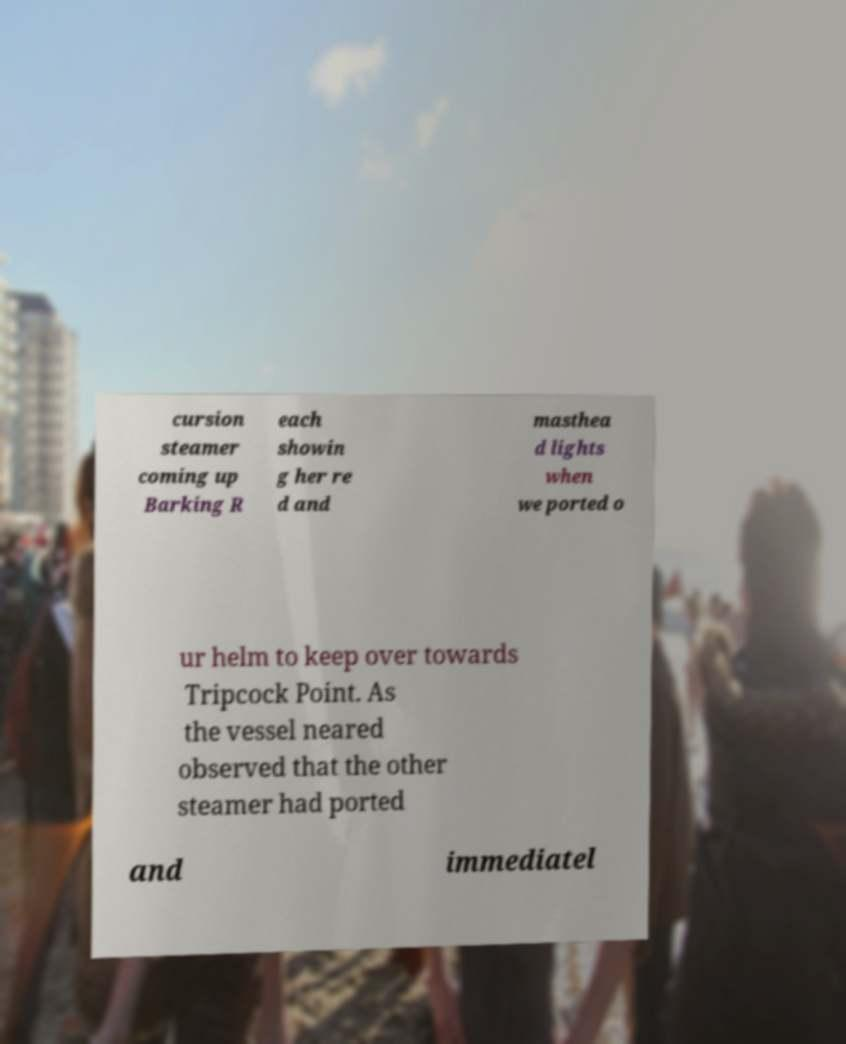For documentation purposes, I need the text within this image transcribed. Could you provide that? cursion steamer coming up Barking R each showin g her re d and masthea d lights when we ported o ur helm to keep over towards Tripcock Point. As the vessel neared observed that the other steamer had ported and immediatel 